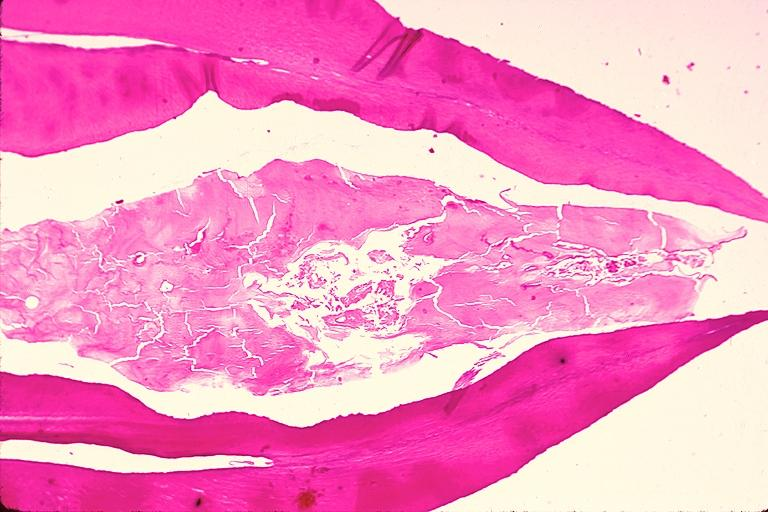s oral present?
Answer the question using a single word or phrase. Yes 